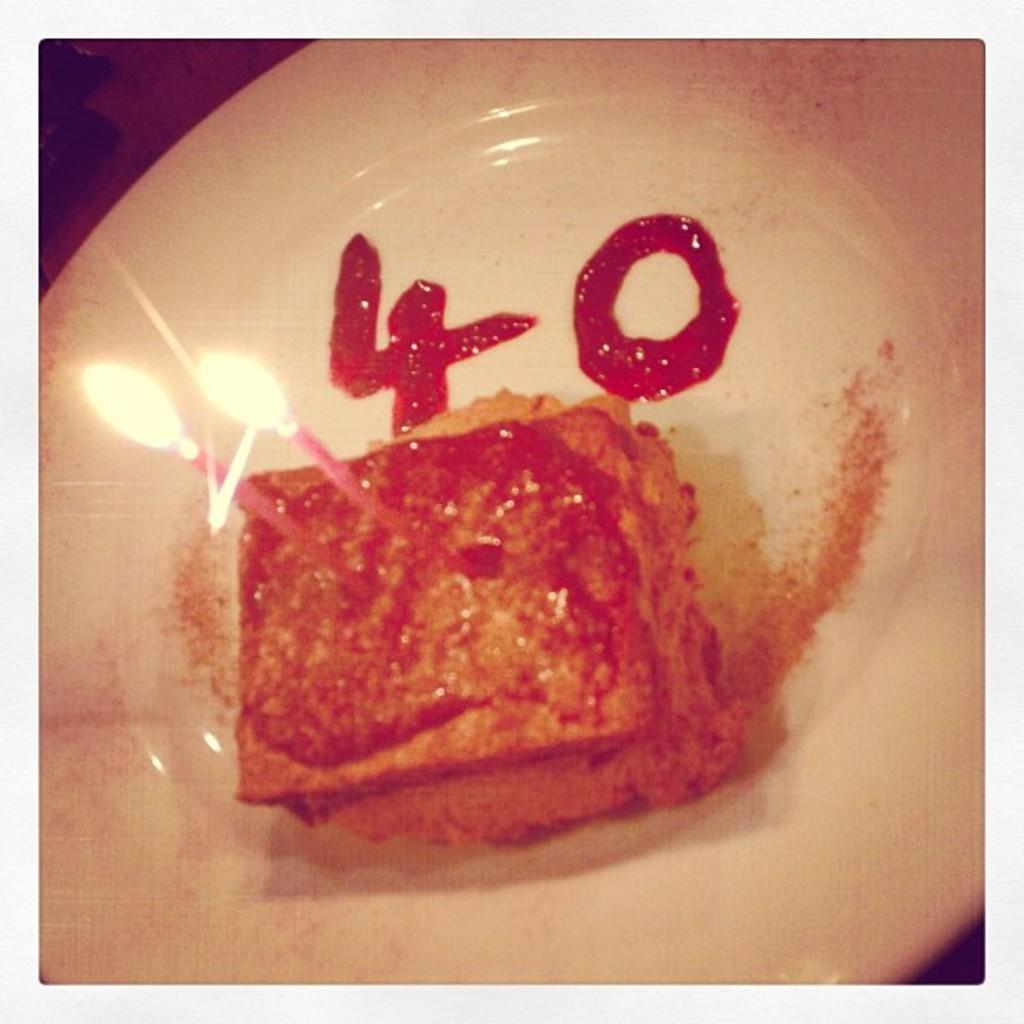Please provide a concise description of this image. In this image there is a cake with two candles on it , and numbers four and zero written with jam on the plate. 